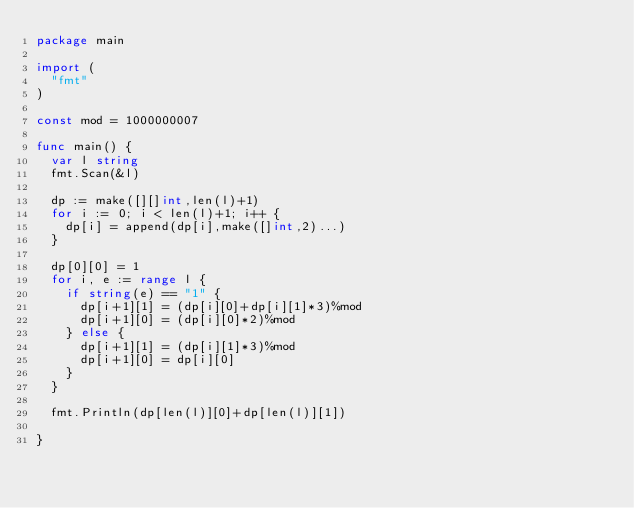<code> <loc_0><loc_0><loc_500><loc_500><_Go_>package main

import (
	"fmt"
)

const mod = 1000000007

func main() {
	var l string
	fmt.Scan(&l)

	dp := make([][]int,len(l)+1)
	for i := 0; i < len(l)+1; i++ {
		dp[i] = append(dp[i],make([]int,2)...)
	}

	dp[0][0] = 1
	for i, e := range l {
		if string(e) == "1" {
			dp[i+1][1] = (dp[i][0]+dp[i][1]*3)%mod
			dp[i+1][0] = (dp[i][0]*2)%mod
		} else {
			dp[i+1][1] = (dp[i][1]*3)%mod
			dp[i+1][0] = dp[i][0]
		}
	}

	fmt.Println(dp[len(l)][0]+dp[len(l)][1])

}
</code> 